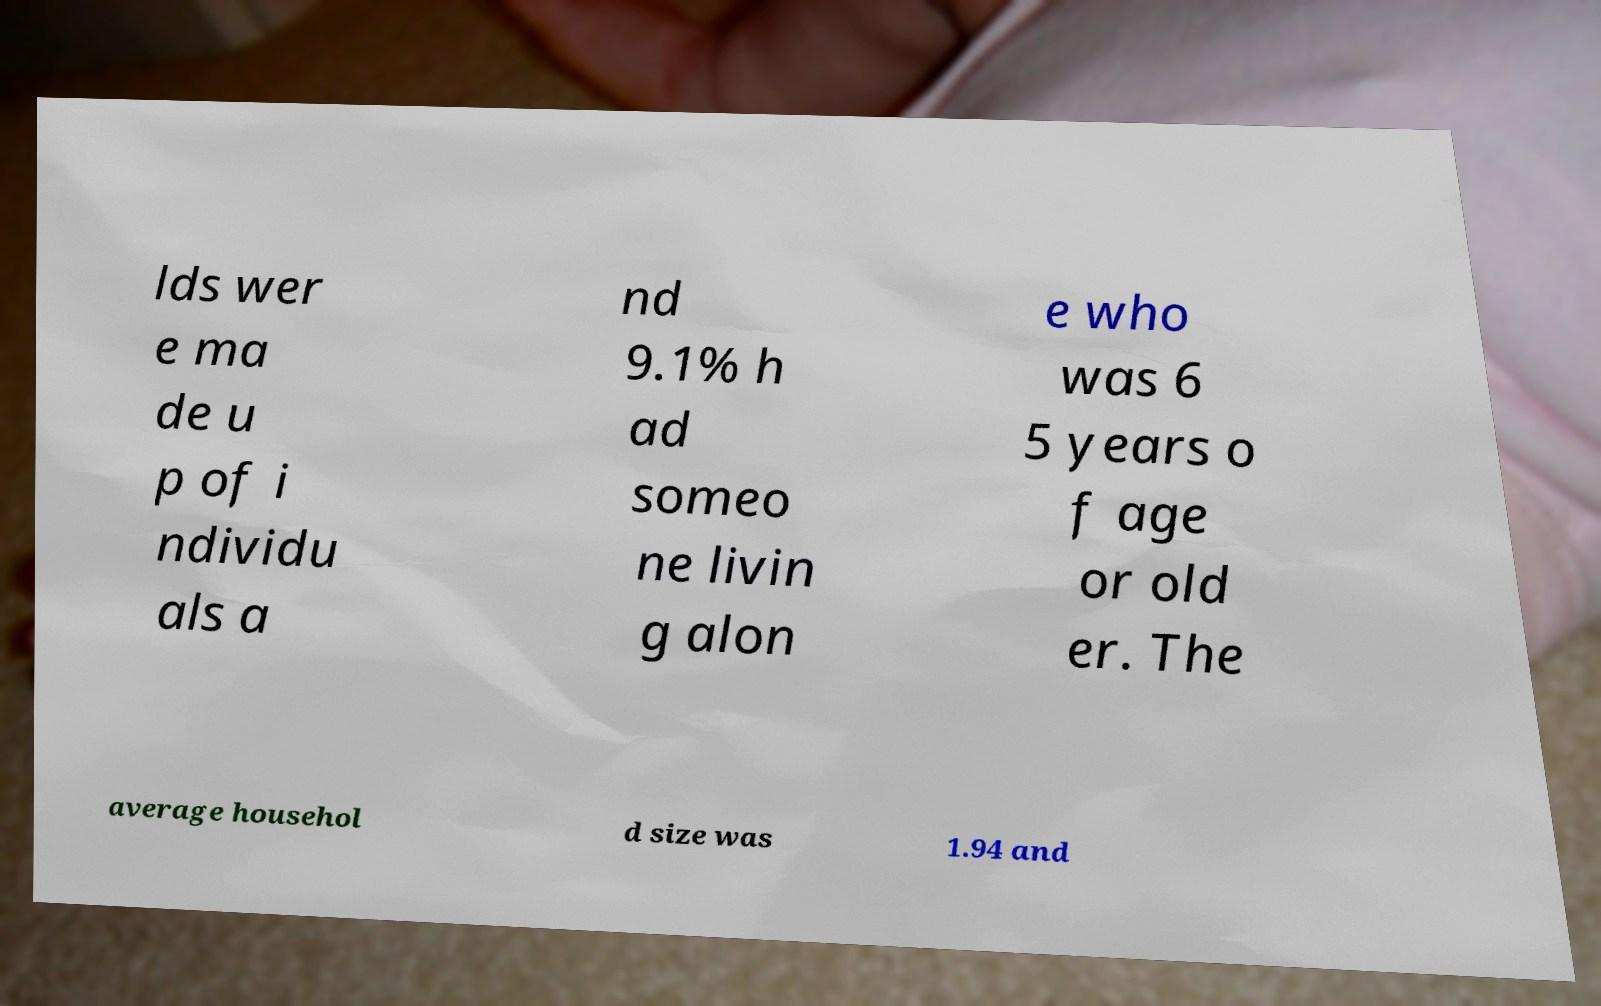There's text embedded in this image that I need extracted. Can you transcribe it verbatim? lds wer e ma de u p of i ndividu als a nd 9.1% h ad someo ne livin g alon e who was 6 5 years o f age or old er. The average househol d size was 1.94 and 